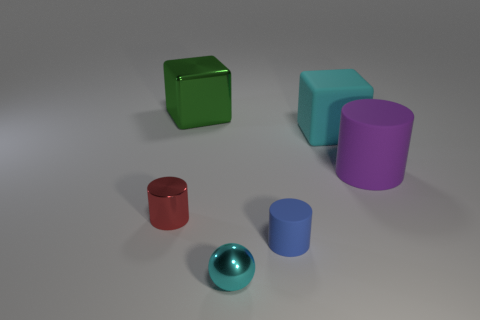Is the color of the large matte cube the same as the tiny metal thing that is right of the green block?
Your answer should be very brief. Yes. Are there an equal number of large rubber objects to the left of the blue object and tiny cyan things that are in front of the purple cylinder?
Ensure brevity in your answer.  No. How many other things are the same size as the red object?
Your answer should be compact. 2. The purple matte object has what size?
Offer a very short reply. Large. Is the material of the large cyan object the same as the big cylinder that is behind the tiny metal sphere?
Give a very brief answer. Yes. Is there another big thing that has the same shape as the big cyan rubber object?
Provide a succinct answer. Yes. What material is the green thing that is the same size as the purple object?
Make the answer very short. Metal. There is a block right of the large green shiny object; what size is it?
Give a very brief answer. Large. Do the cylinder that is in front of the small red object and the rubber cylinder right of the large cyan rubber object have the same size?
Make the answer very short. No. How many other small spheres are made of the same material as the ball?
Your answer should be very brief. 0. 